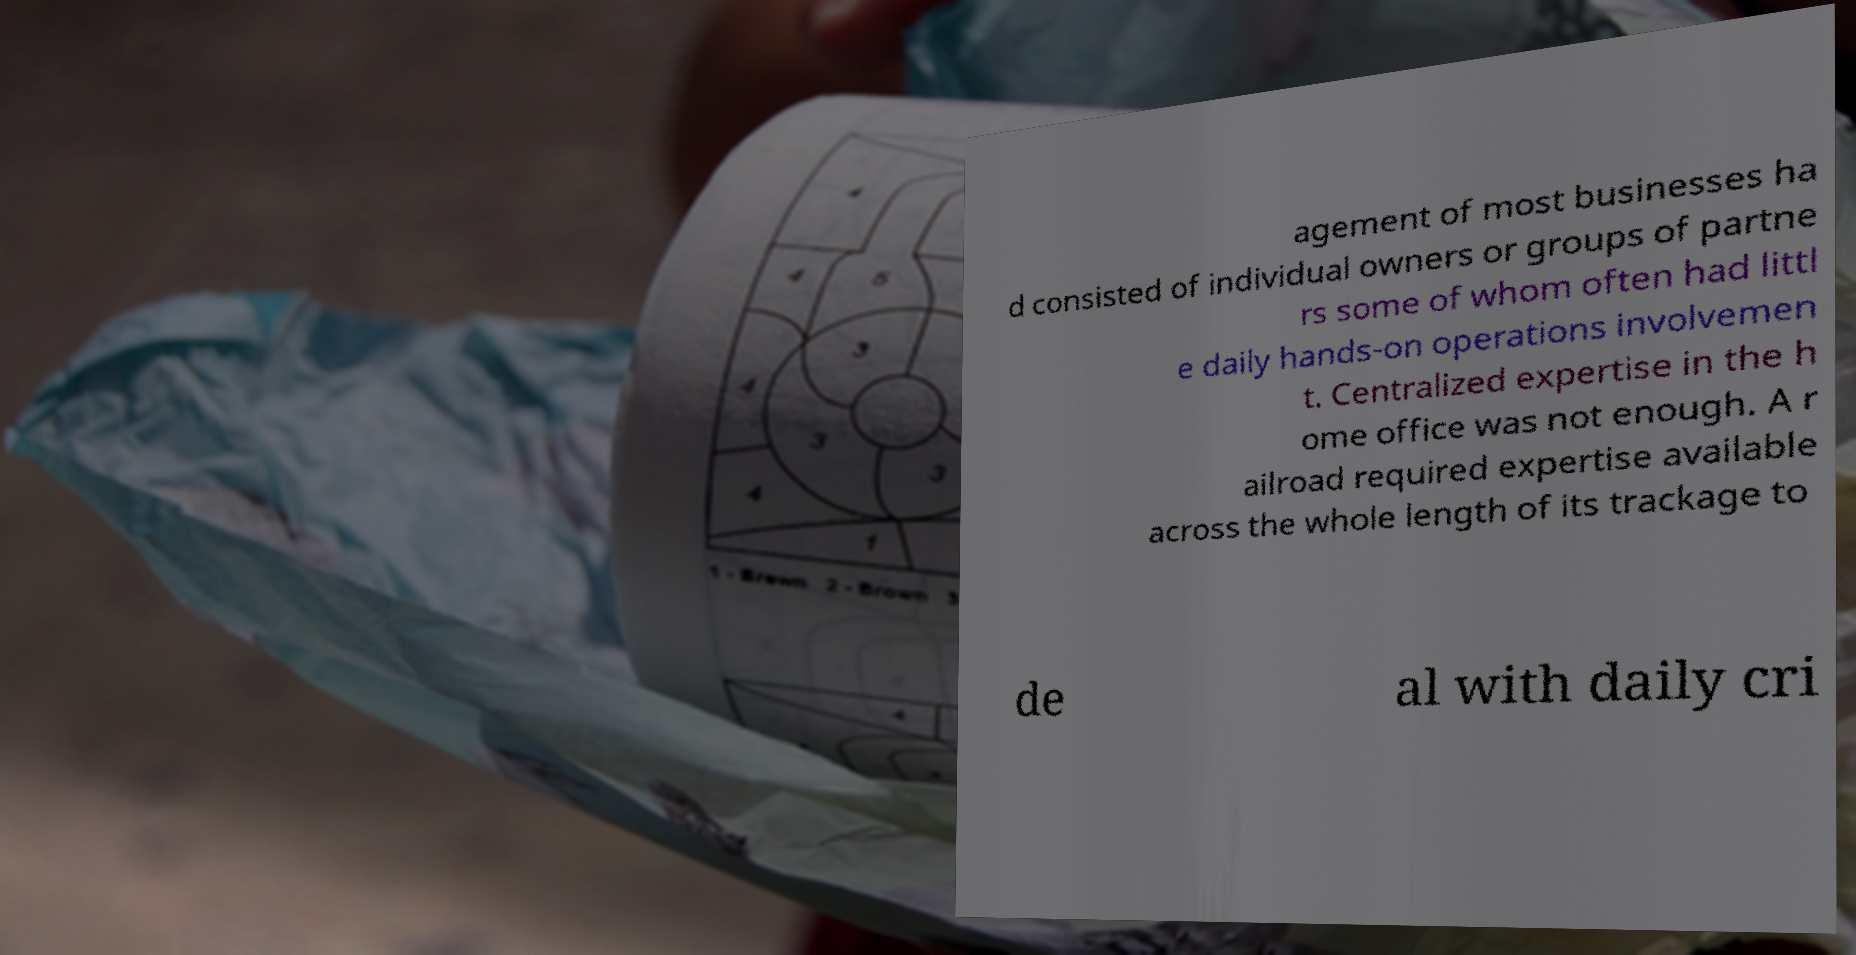Could you extract and type out the text from this image? agement of most businesses ha d consisted of individual owners or groups of partne rs some of whom often had littl e daily hands-on operations involvemen t. Centralized expertise in the h ome office was not enough. A r ailroad required expertise available across the whole length of its trackage to de al with daily cri 